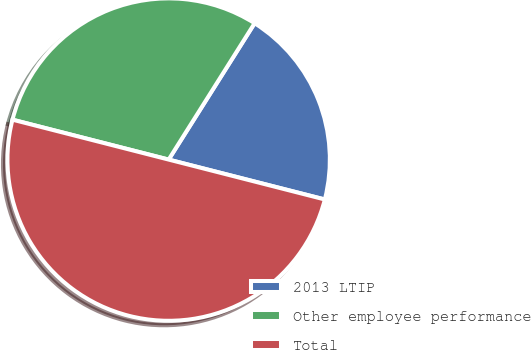<chart> <loc_0><loc_0><loc_500><loc_500><pie_chart><fcel>2013 LTIP<fcel>Other employee performance<fcel>Total<nl><fcel>20.03%<fcel>29.97%<fcel>50.0%<nl></chart> 